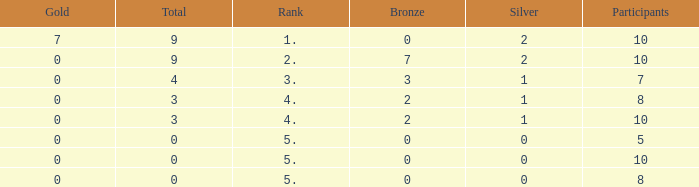What is recorded as the maximum participants having a rank of 5, and silver below 0? None. 